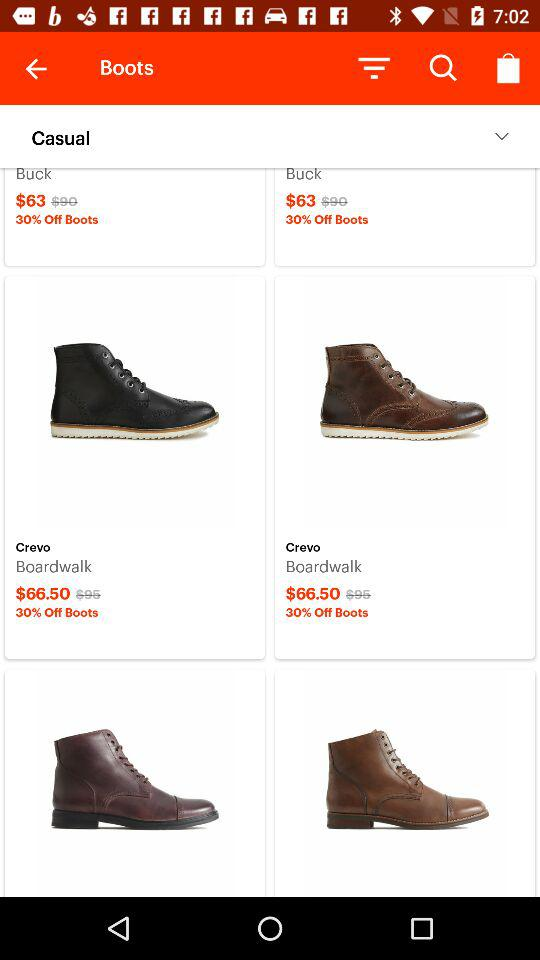What is the cost of the buck? The cost of the buck is $63. 